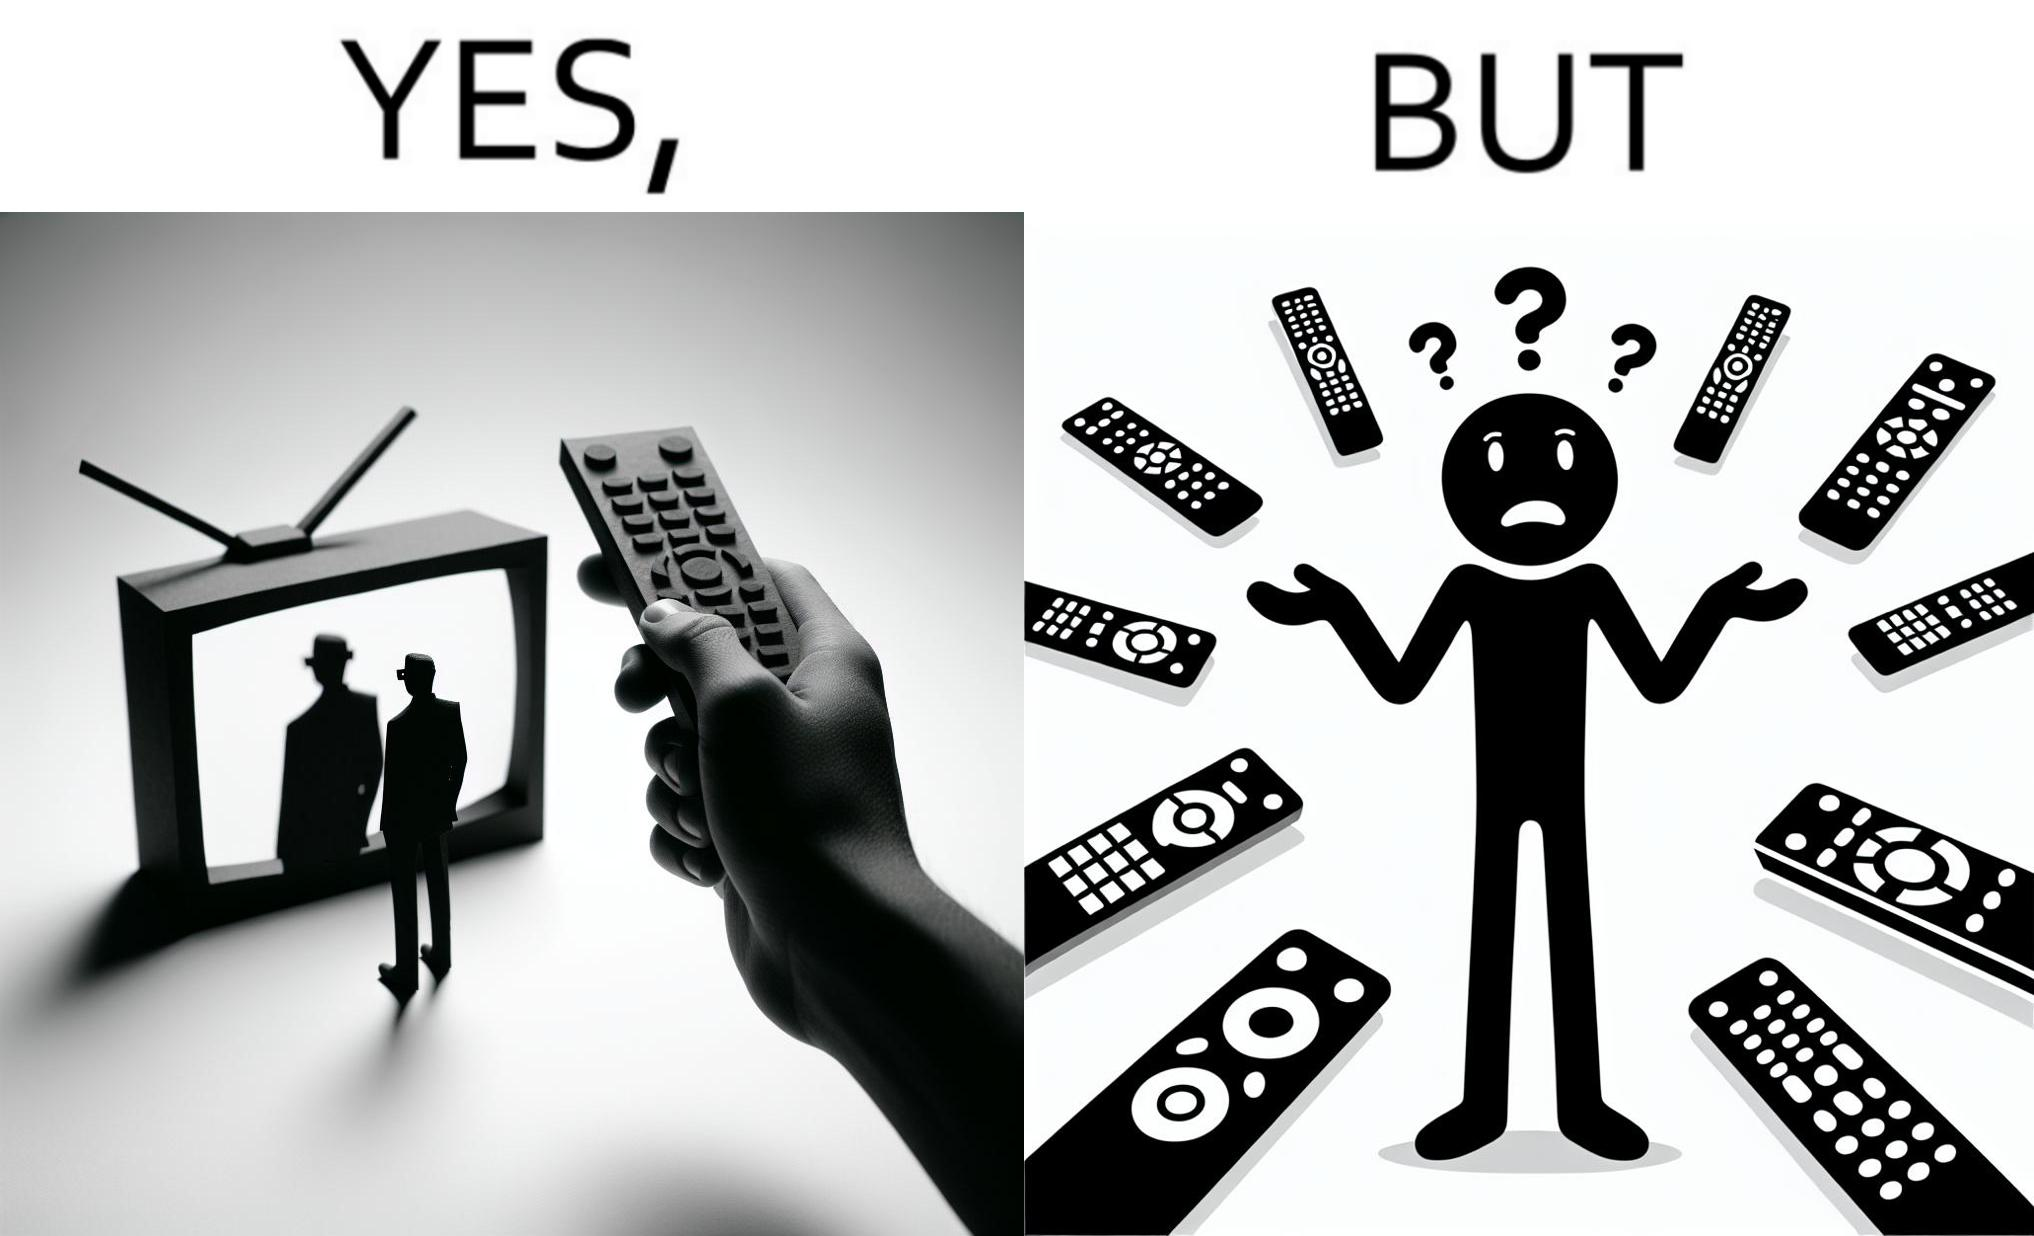What makes this image funny or satirical? The images are funny since they show how even though TV remotes are supposed to make operating TVs easier, having multiple similar looking remotes  for everything only makes it more difficult for the user to use the right one 